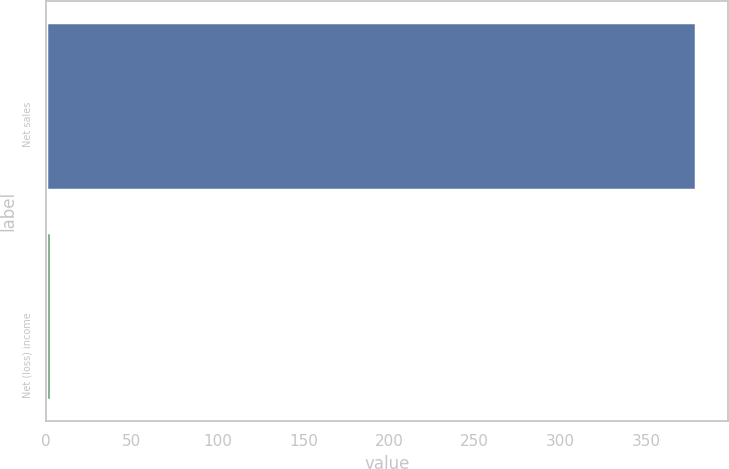Convert chart. <chart><loc_0><loc_0><loc_500><loc_500><bar_chart><fcel>Net sales<fcel>Net (loss) income<nl><fcel>379<fcel>3<nl></chart> 